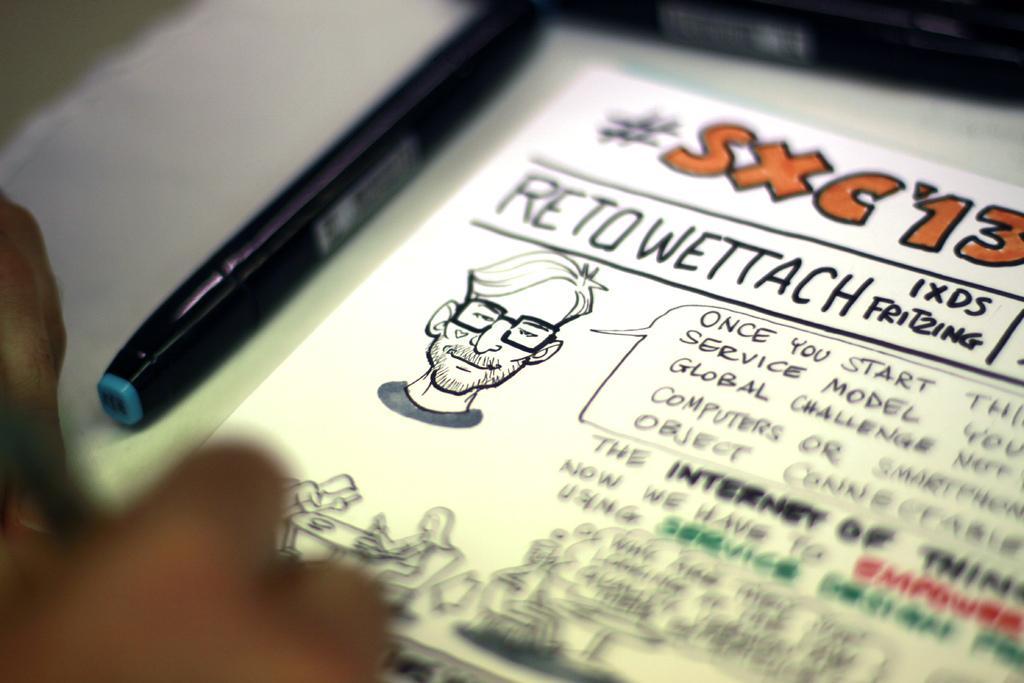Describe this image in one or two sentences. In this image we can see persons hand. There is a paper with some text and persons depiction and there is a pen. 